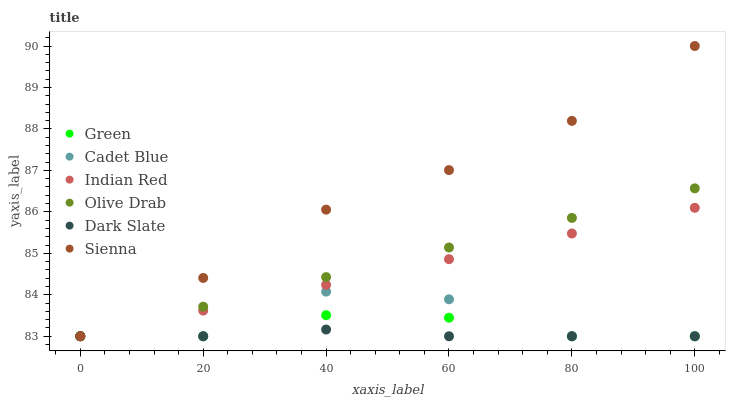Does Dark Slate have the minimum area under the curve?
Answer yes or no. Yes. Does Sienna have the maximum area under the curve?
Answer yes or no. Yes. Does Sienna have the minimum area under the curve?
Answer yes or no. No. Does Dark Slate have the maximum area under the curve?
Answer yes or no. No. Is Olive Drab the smoothest?
Answer yes or no. Yes. Is Cadet Blue the roughest?
Answer yes or no. Yes. Is Sienna the smoothest?
Answer yes or no. No. Is Sienna the roughest?
Answer yes or no. No. Does Cadet Blue have the lowest value?
Answer yes or no. Yes. Does Sienna have the highest value?
Answer yes or no. Yes. Does Dark Slate have the highest value?
Answer yes or no. No. Does Sienna intersect Green?
Answer yes or no. Yes. Is Sienna less than Green?
Answer yes or no. No. Is Sienna greater than Green?
Answer yes or no. No. 